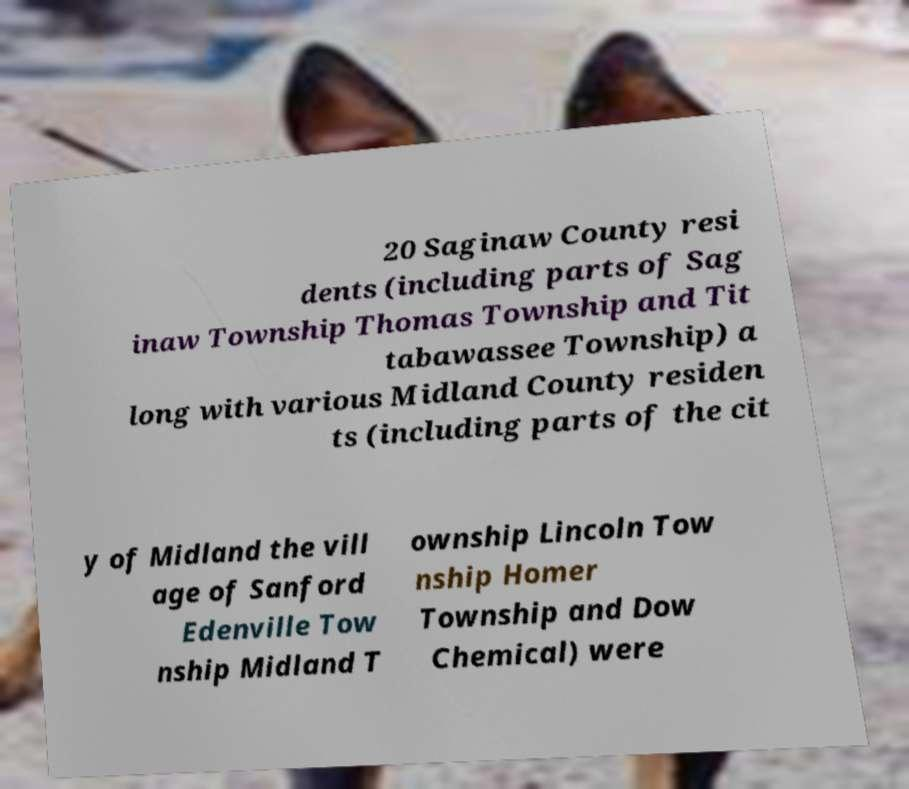For documentation purposes, I need the text within this image transcribed. Could you provide that? 20 Saginaw County resi dents (including parts of Sag inaw Township Thomas Township and Tit tabawassee Township) a long with various Midland County residen ts (including parts of the cit y of Midland the vill age of Sanford Edenville Tow nship Midland T ownship Lincoln Tow nship Homer Township and Dow Chemical) were 